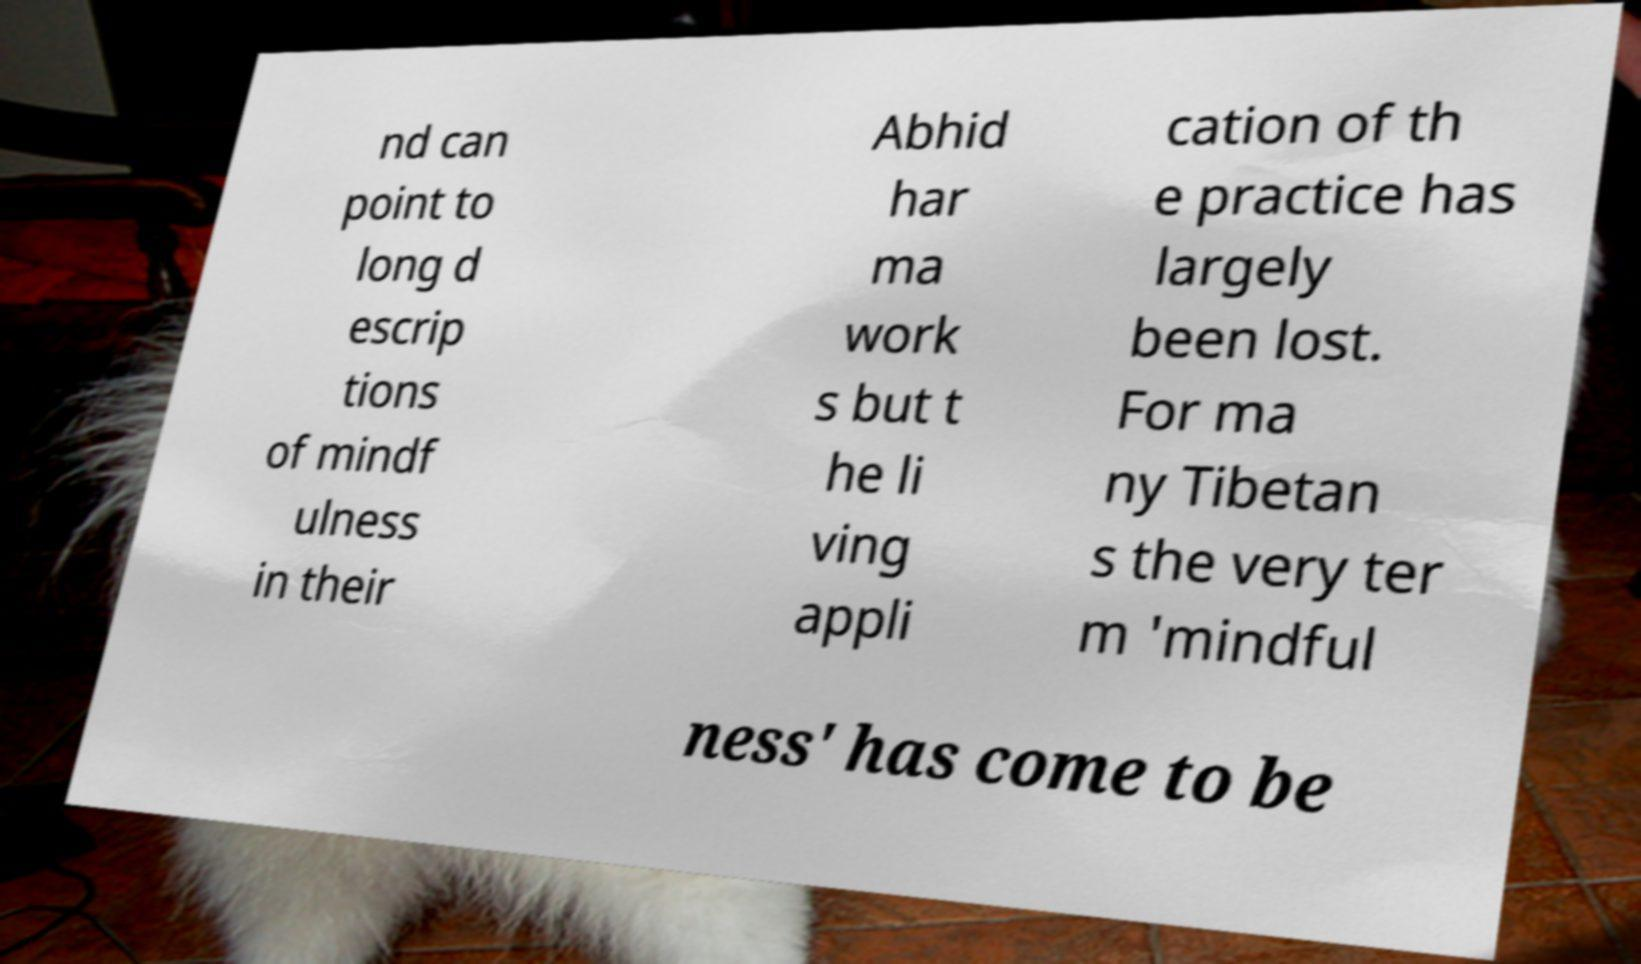Please read and relay the text visible in this image. What does it say? nd can point to long d escrip tions of mindf ulness in their Abhid har ma work s but t he li ving appli cation of th e practice has largely been lost. For ma ny Tibetan s the very ter m 'mindful ness' has come to be 